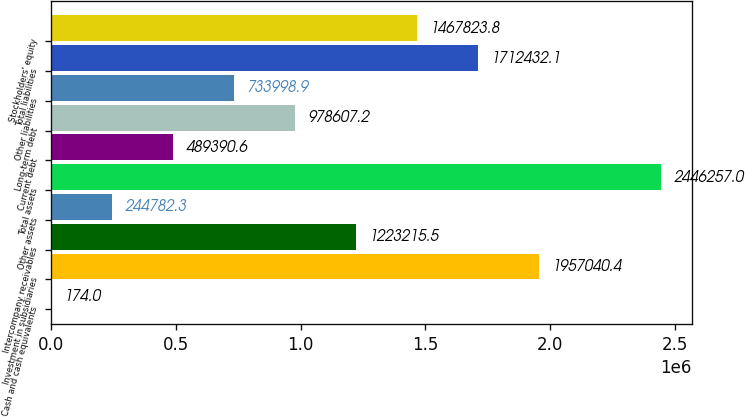Convert chart to OTSL. <chart><loc_0><loc_0><loc_500><loc_500><bar_chart><fcel>Cash and cash equivalents<fcel>Investment in subsidiaries<fcel>Intercompany receivables<fcel>Other assets<fcel>Total assets<fcel>Current debt<fcel>Long-term debt<fcel>Other liabilities<fcel>Total liabilities<fcel>Stockholders' equity<nl><fcel>174<fcel>1.95704e+06<fcel>1.22322e+06<fcel>244782<fcel>2.44626e+06<fcel>489391<fcel>978607<fcel>733999<fcel>1.71243e+06<fcel>1.46782e+06<nl></chart> 